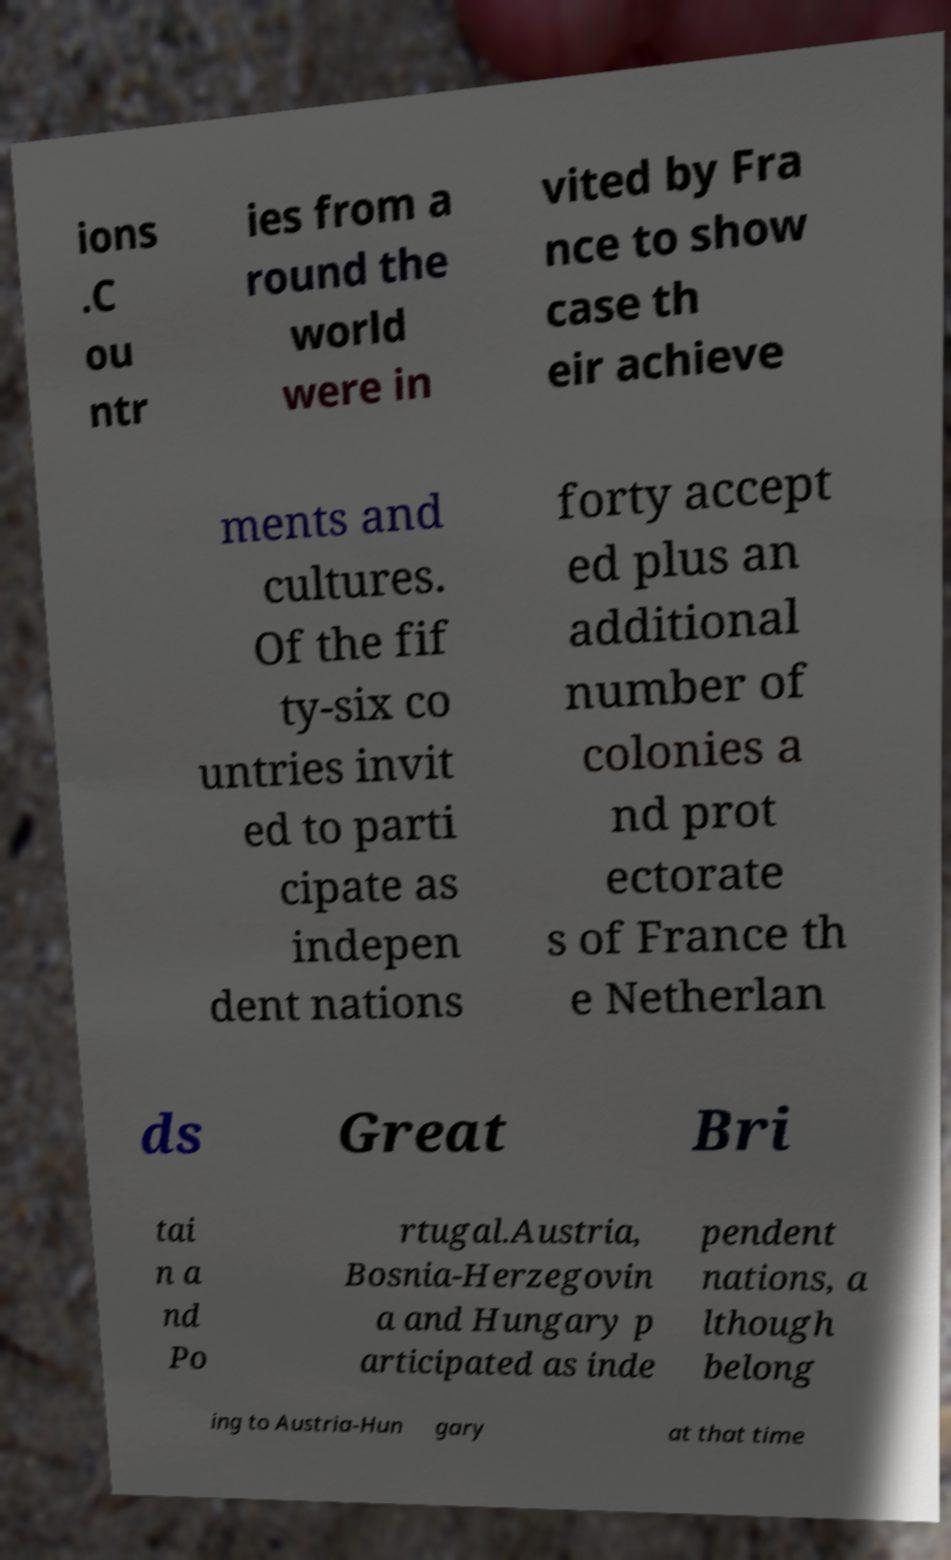What messages or text are displayed in this image? I need them in a readable, typed format. ions .C ou ntr ies from a round the world were in vited by Fra nce to show case th eir achieve ments and cultures. Of the fif ty-six co untries invit ed to parti cipate as indepen dent nations forty accept ed plus an additional number of colonies a nd prot ectorate s of France th e Netherlan ds Great Bri tai n a nd Po rtugal.Austria, Bosnia-Herzegovin a and Hungary p articipated as inde pendent nations, a lthough belong ing to Austria-Hun gary at that time 